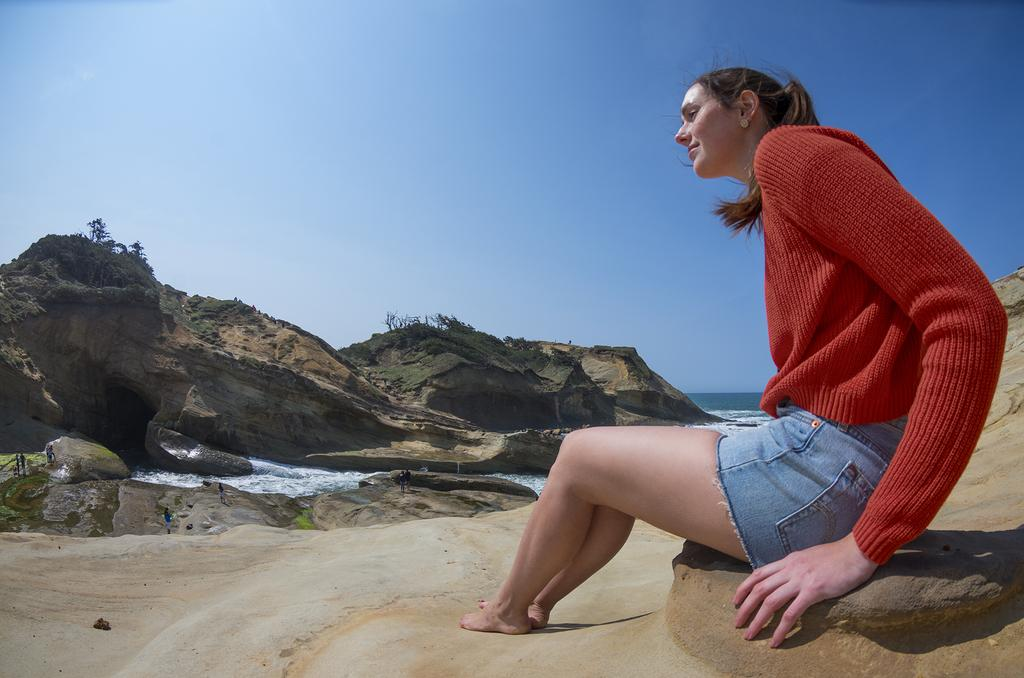What is the girl in the image sitting on? The girl is sitting on a stone. What can be seen in the background of the image? There is water, rocks, plants, grass, and the sky visible in the background. Can you describe the natural environment in the image? The natural environment includes water, rocks, plants, and grass. What type of bun is the girl holding in the image? There is no bun present in the image; the girl is sitting on a stone with no visible objects in her hands. 